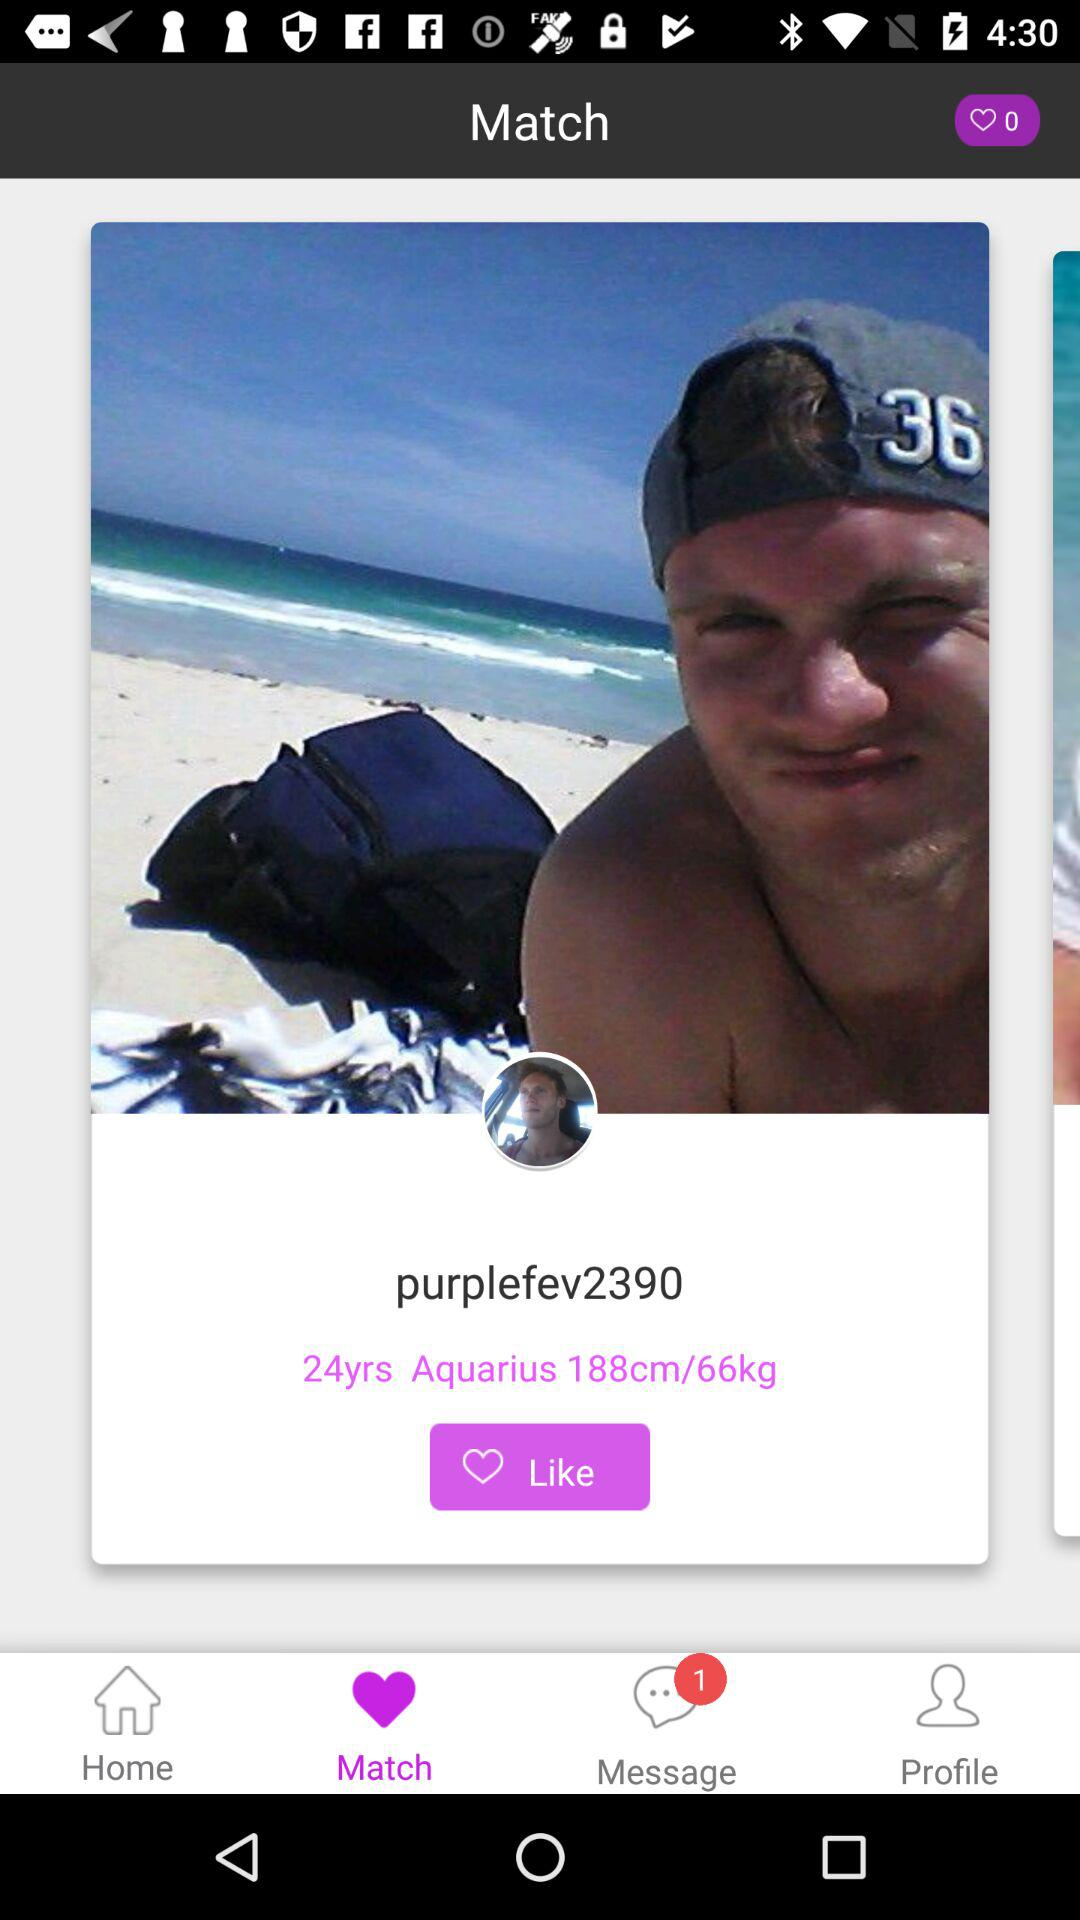What is the height of the "purplefev2390"? The height is 188 cm. 